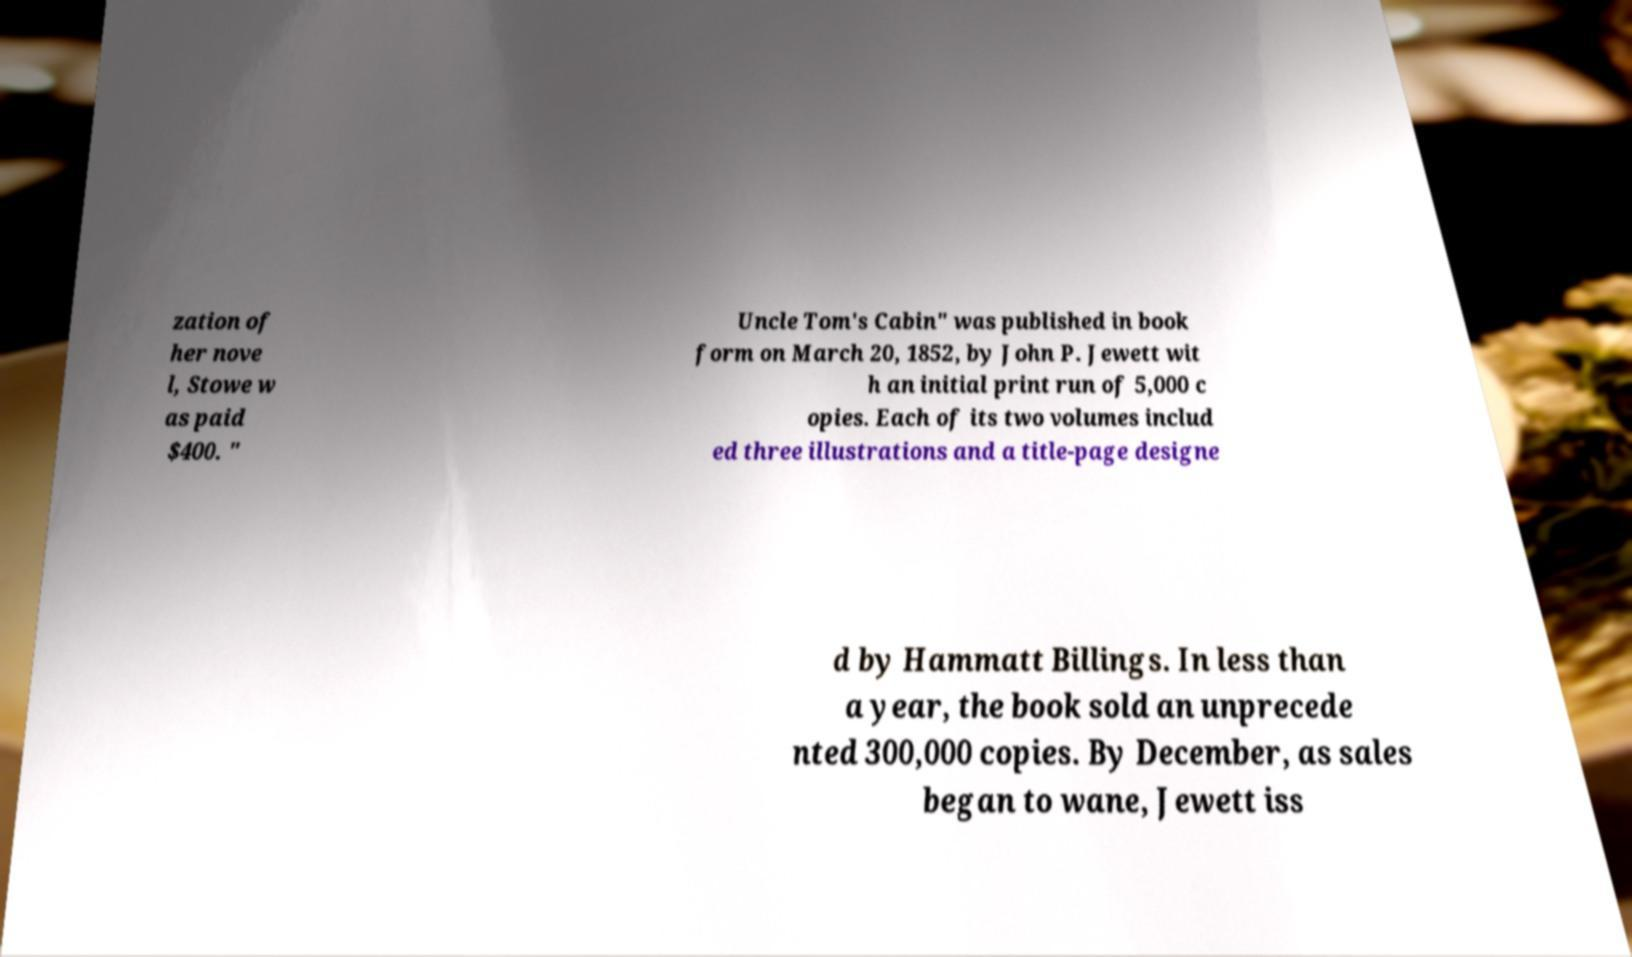Could you extract and type out the text from this image? zation of her nove l, Stowe w as paid $400. " Uncle Tom's Cabin" was published in book form on March 20, 1852, by John P. Jewett wit h an initial print run of 5,000 c opies. Each of its two volumes includ ed three illustrations and a title-page designe d by Hammatt Billings. In less than a year, the book sold an unprecede nted 300,000 copies. By December, as sales began to wane, Jewett iss 